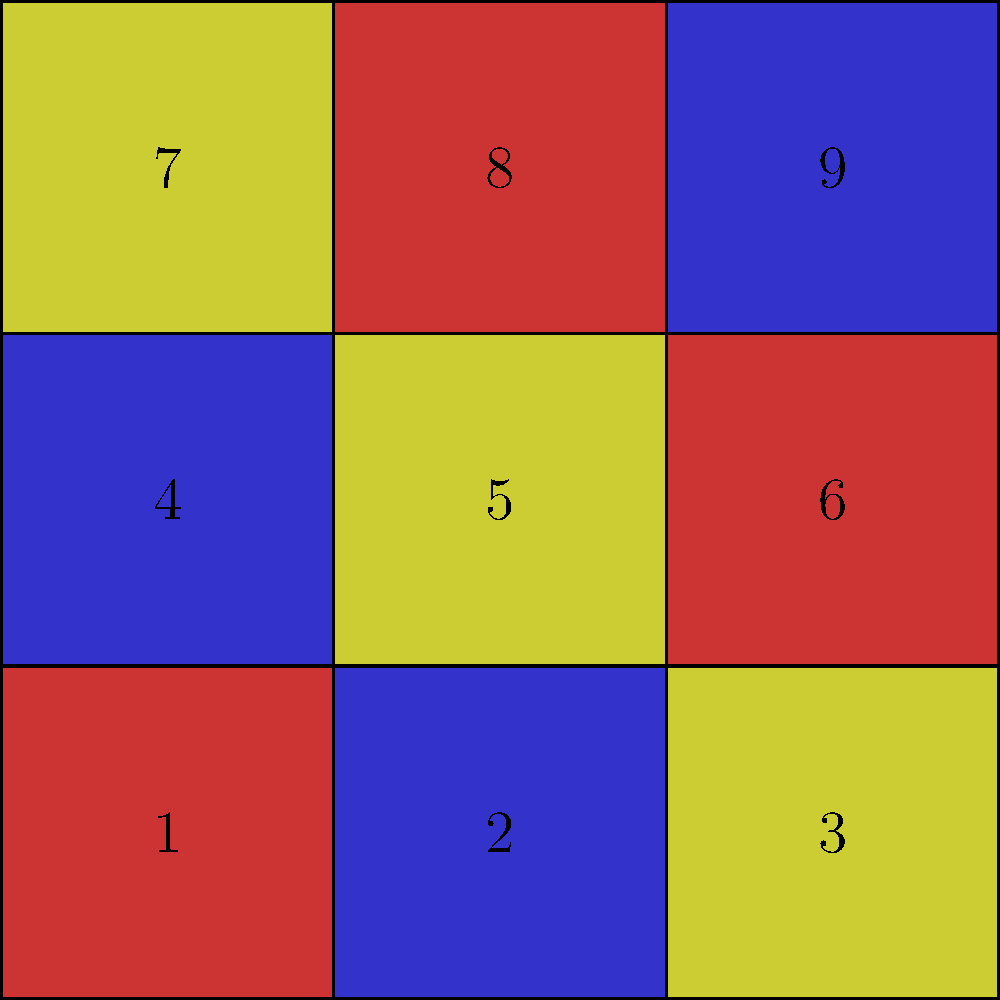Imagine you have 9 Little Richard album covers represented by the colored squares in the grid above. Each color represents a different album: red for "Here's Little Richard", blue for "Little Richard", and yellow for "The Fabulous Little Richard". To create a tribute display, you need to arrange these albums so that no color appears more than once in any row, column, or diagonal. Which number should the yellow album in the top right corner (position 3) move to in order to satisfy this condition? Let's approach this step-by-step:

1. First, we need to identify the current arrangement:
   - Red: positions 1, 6, 8
   - Blue: positions 2, 4, 9
   - Yellow: positions 3, 5, 7

2. We can see that the yellow album in position 3 is causing conflicts:
   - It's in the same row as the yellow album in position 1
   - It's in the same diagonal as the yellow album in position 5

3. To resolve these conflicts, we need to move the yellow album from position 3.

4. Let's consider the available positions:
   - It can't go to positions 1, 5, or 7 (yellow already present)
   - It can't go to positions 2, 4, or 9 (blue already present)
   - It can't go to positions 6 or 8 (red already present)

5. The only remaining position is 4.

6. If we move the yellow album to position 4:
   - No color appears more than once in any row
   - No color appears more than once in any column
   - No color appears more than once in any diagonal

Therefore, the yellow album in position 3 should move to position 4 to satisfy the condition.
Answer: 4 